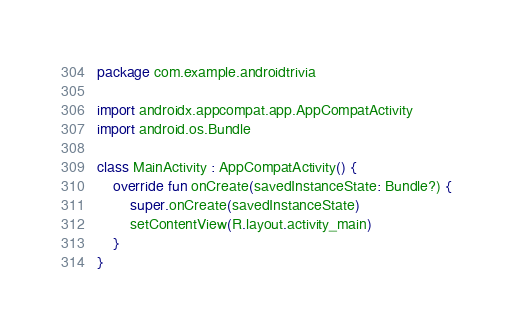<code> <loc_0><loc_0><loc_500><loc_500><_Kotlin_>package com.example.androidtrivia

import androidx.appcompat.app.AppCompatActivity
import android.os.Bundle

class MainActivity : AppCompatActivity() {
    override fun onCreate(savedInstanceState: Bundle?) {
        super.onCreate(savedInstanceState)
        setContentView(R.layout.activity_main)
    }
}</code> 